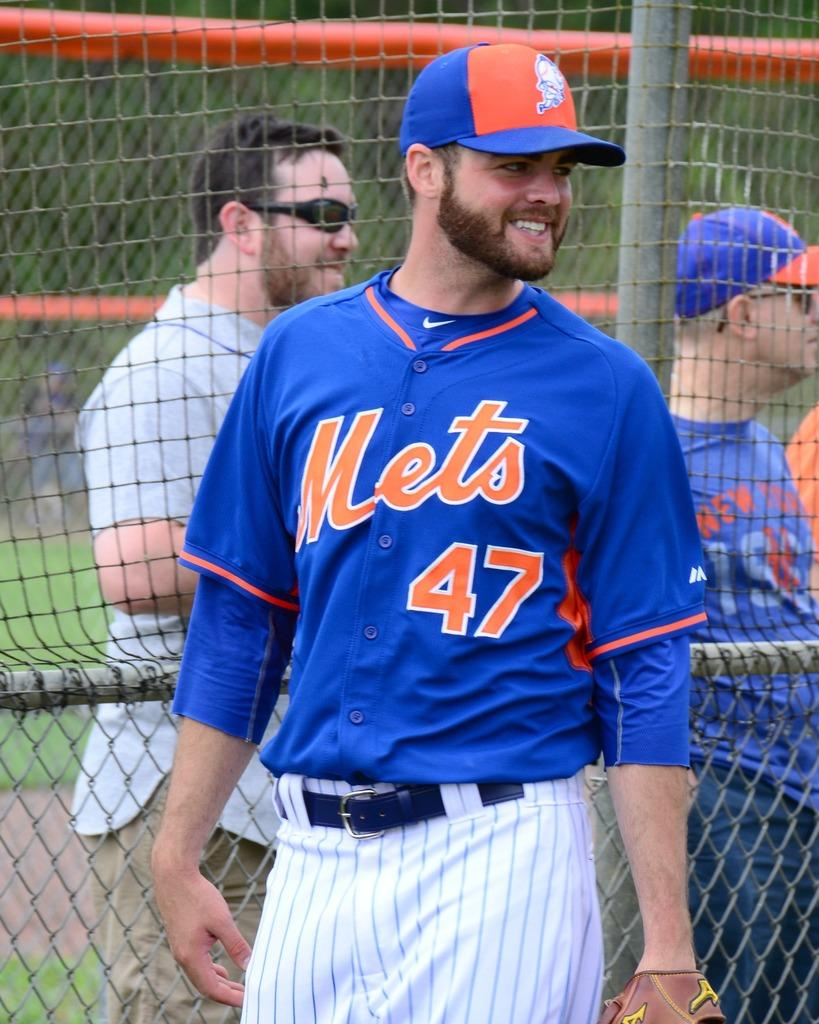<image>
Offer a succinct explanation of the picture presented. Mets player number 47 smiles and looks off to his left. 